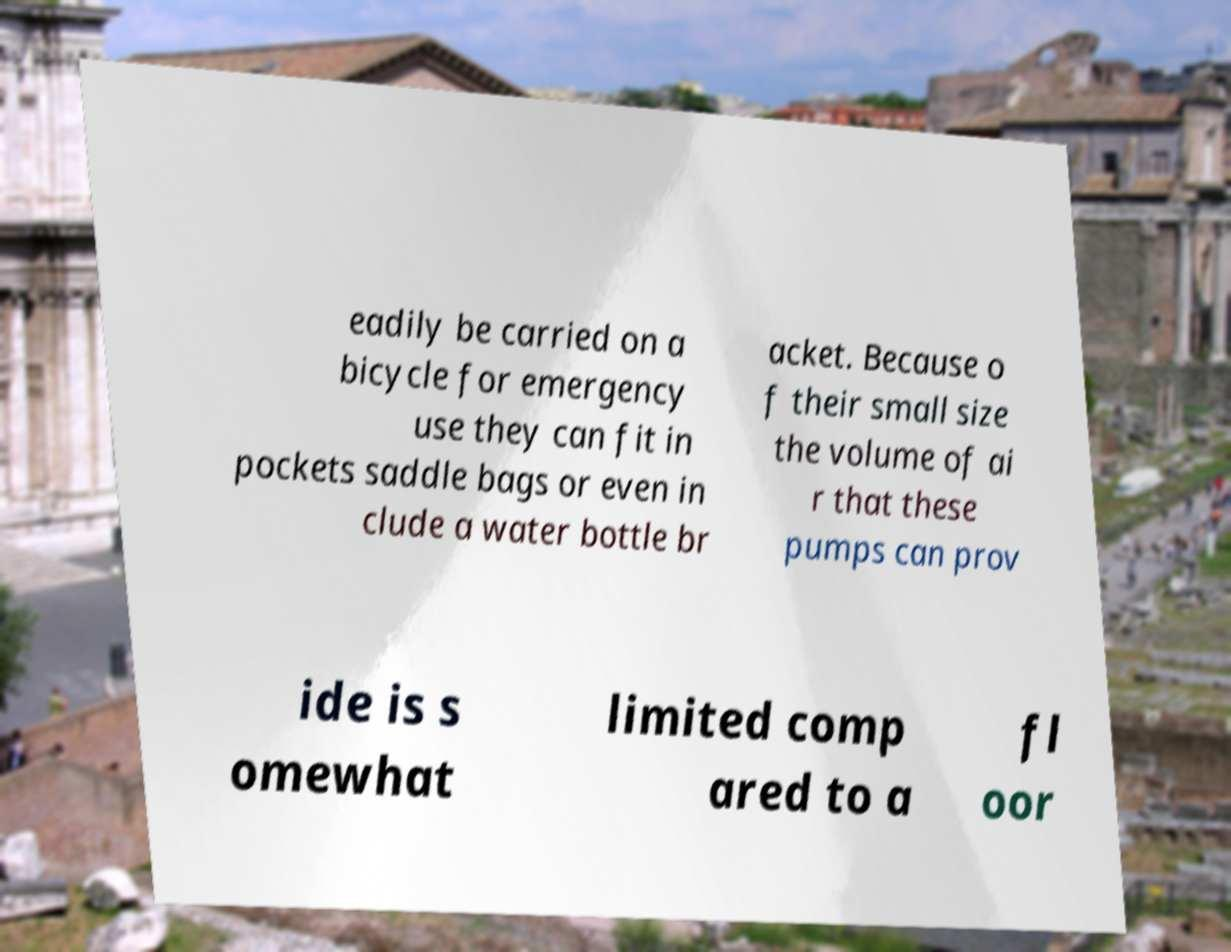Could you extract and type out the text from this image? eadily be carried on a bicycle for emergency use they can fit in pockets saddle bags or even in clude a water bottle br acket. Because o f their small size the volume of ai r that these pumps can prov ide is s omewhat limited comp ared to a fl oor 